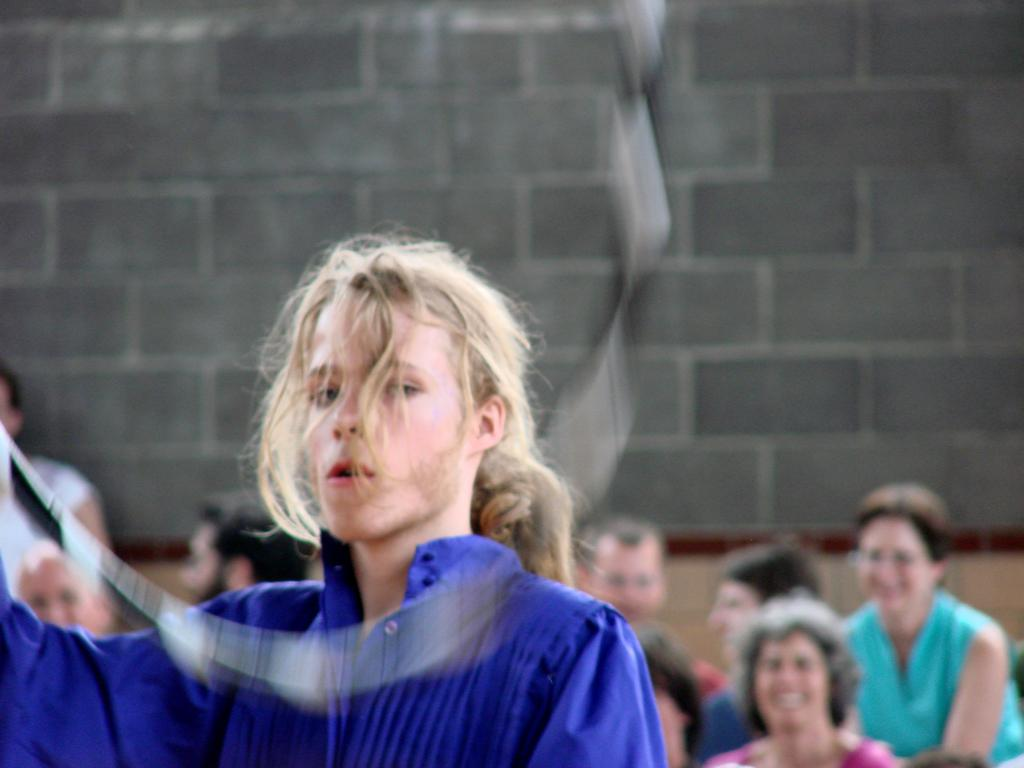Who or what is present in the image? There are people in the image. What can be observed about the background of the image? The background of the image is blurred. What type of structure is visible in the image? There is a wall in the image. What type of polish is being applied to the ring in the image? There is no ring or polish present in the image; it features people and a wall. Can you tell me how many moms are visible in the image? The term "mom" is not mentioned in the provided facts, and therefore it cannot be determined from the image. 